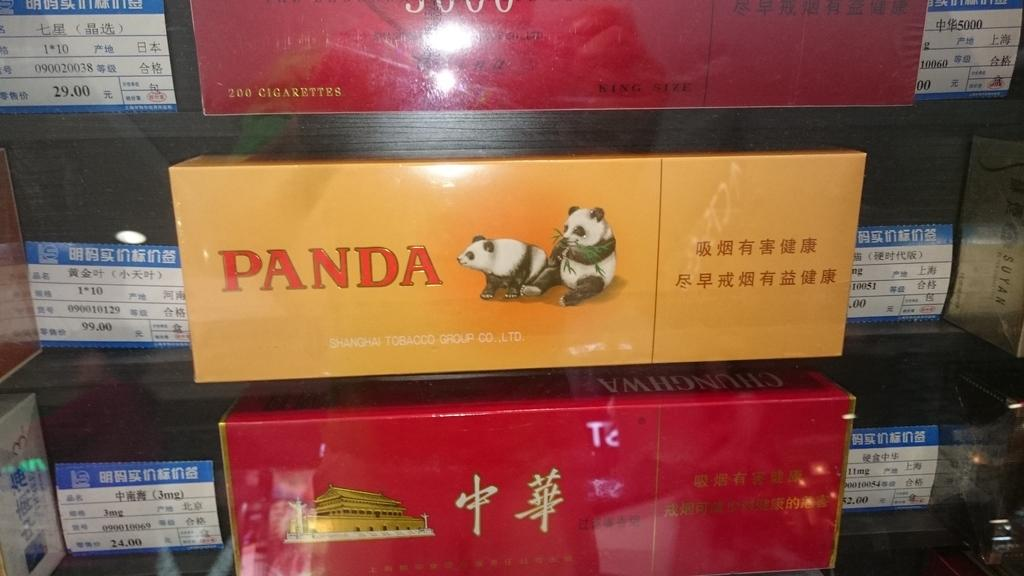What objects are present in the image? There are boxes in the image. Can you describe the appearance of the boxes? The boxes have different colors. Is there any text or symbols on the boxes? Yes, there is writing on the boxes. What type of mountain can be seen in the background of the image? There is no mountain present in the image; it only features boxes with different colors and writing on them. 